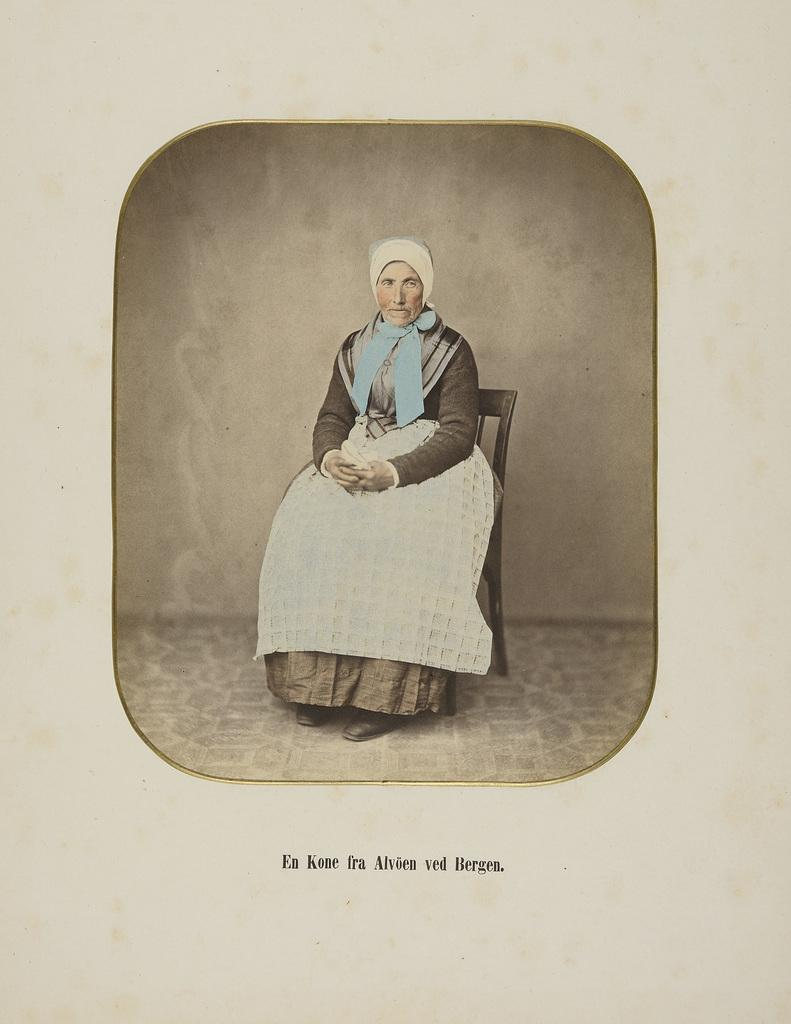Who is the main subject in the image? There is a woman in the image. What is the woman doing in the image? The woman is sitting on a chair. Is there any text present in the image? Yes, there is text written at the bottom of the image. What type of nail is the woman holding in the image? There is no nail present in the image. Can you see a snake in the image? No, there is no snake present in the image. 